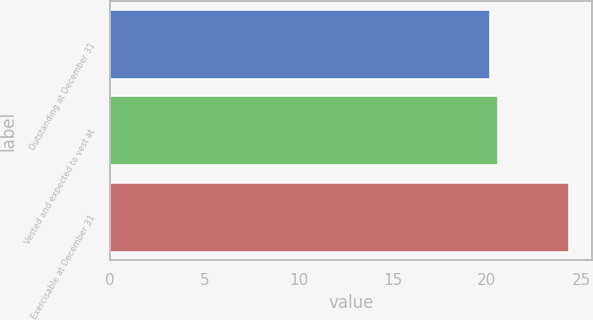<chart> <loc_0><loc_0><loc_500><loc_500><bar_chart><fcel>Outstanding at December 31<fcel>Vested and expected to vest at<fcel>Exercisable at December 31<nl><fcel>20.18<fcel>20.6<fcel>24.34<nl></chart> 